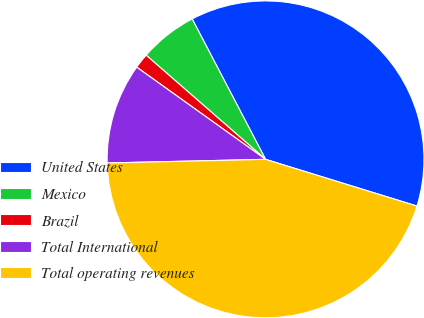<chart> <loc_0><loc_0><loc_500><loc_500><pie_chart><fcel>United States<fcel>Mexico<fcel>Brazil<fcel>Total International<fcel>Total operating revenues<nl><fcel>37.43%<fcel>5.92%<fcel>1.53%<fcel>10.25%<fcel>44.87%<nl></chart> 